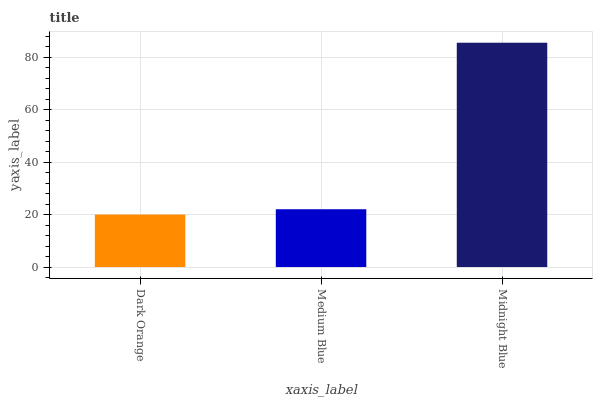Is Dark Orange the minimum?
Answer yes or no. Yes. Is Midnight Blue the maximum?
Answer yes or no. Yes. Is Medium Blue the minimum?
Answer yes or no. No. Is Medium Blue the maximum?
Answer yes or no. No. Is Medium Blue greater than Dark Orange?
Answer yes or no. Yes. Is Dark Orange less than Medium Blue?
Answer yes or no. Yes. Is Dark Orange greater than Medium Blue?
Answer yes or no. No. Is Medium Blue less than Dark Orange?
Answer yes or no. No. Is Medium Blue the high median?
Answer yes or no. Yes. Is Medium Blue the low median?
Answer yes or no. Yes. Is Midnight Blue the high median?
Answer yes or no. No. Is Dark Orange the low median?
Answer yes or no. No. 